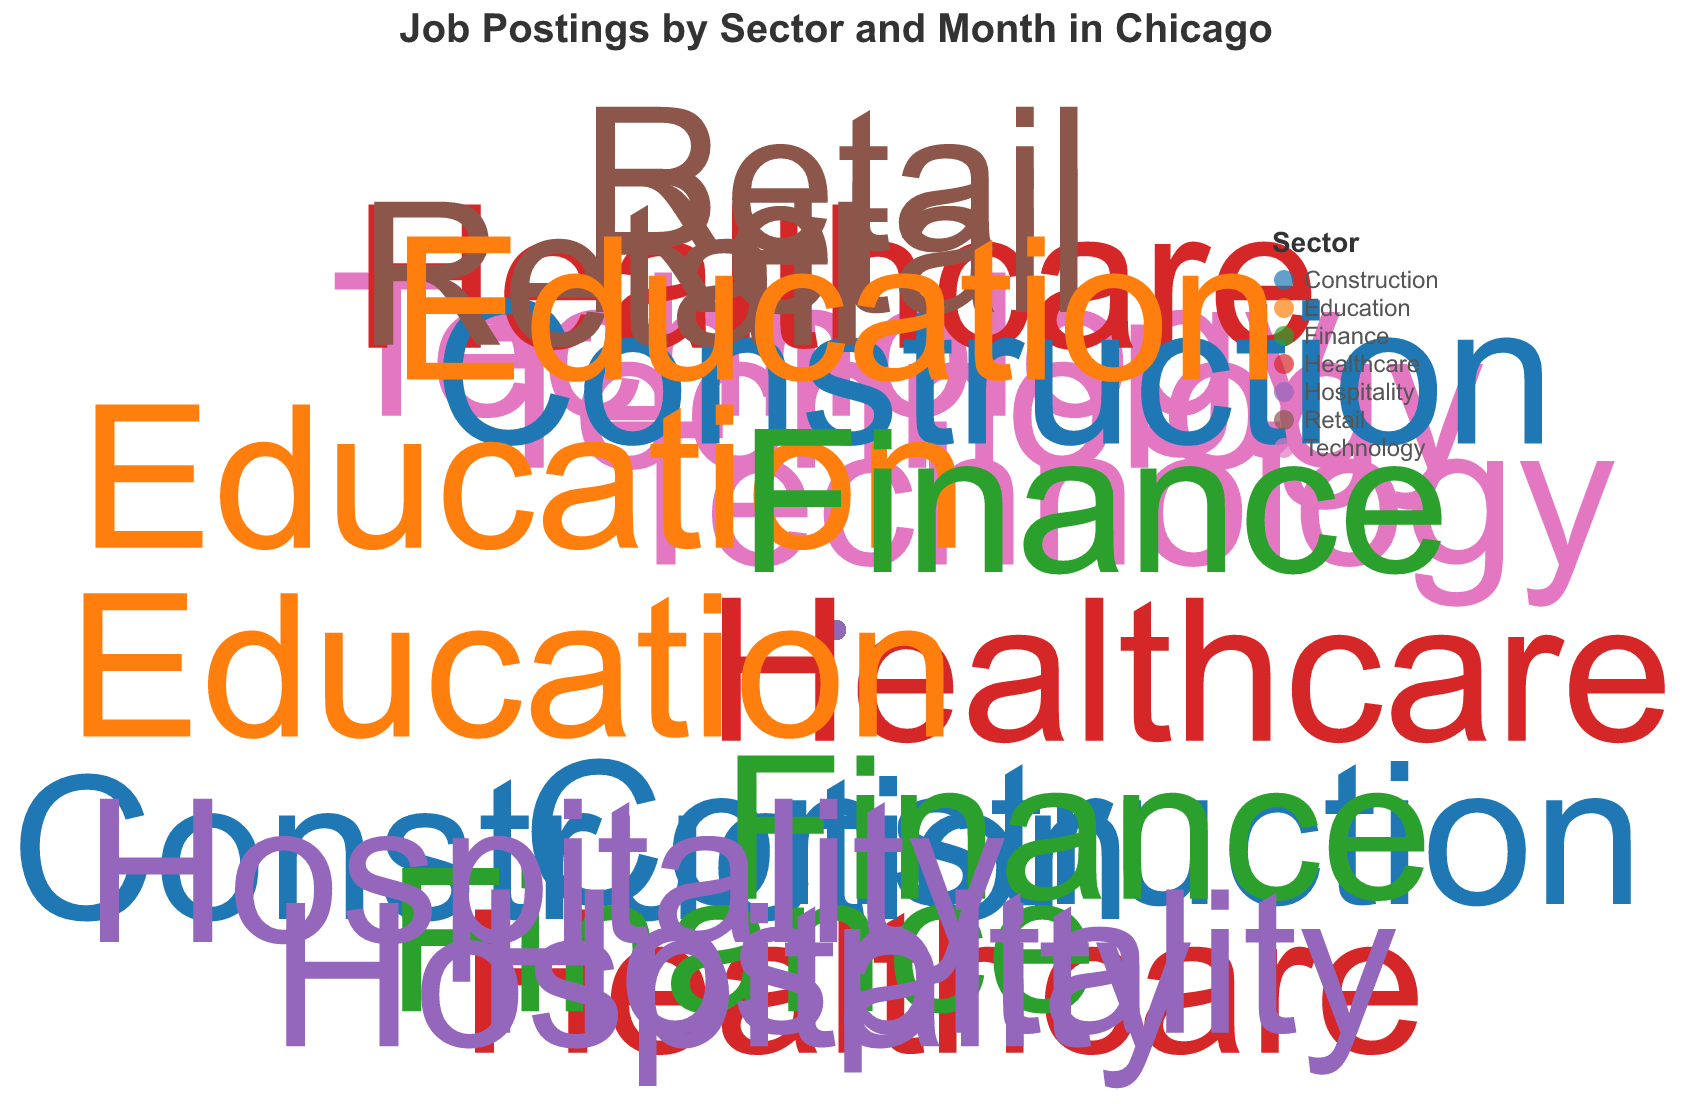What sector has the highest number of job postings in December? Look for the marker corresponding to December and check the sector with the highest radius (job postings). In December, Retail has the highest number of job postings with 350 from Walmart.
Answer: Retail Which month has the highest job postings for the Healthcare sector? Check the radius (job postings) for each Healthcare sector marker by month. The largest radius for Healthcare is in June, with 250 job postings from UChicago Medicine.
Answer: June In which month does the Construction sector have the lowest job postings? Look through all months for the Construction sector data points and find the one with the smallest radius. The smallest radius is February, with 140 job postings from Turner Construction.
Answer: February Which sectors have job postings in July, and what are the job postings for each? Identify all markers for the month of July and note their respective sectors and job postings. The sectors in July are Finance with 190 job postings (Goldman Sachs) and Hospitality with 240 job postings (Hilton Hotels).
Answer: Finance (190), Hospitality (240) What are the total job postings for the Retail sector over all months? Sum the job postings for the Retail sector across all listed months. January (250) + November (300) + December (350) = 900.
Answer: 900 Which sector has a job posting in August and a different one in May, and how many job postings are in each month? Check the markers for August and May, then identify and compare sectors. Construction has job postings in August (210 from Skender Construction) and May (180 from Clark Construction).
Answer: Construction, 210 in August, 180 in May How do job postings for the Education sector in October compare to the job postings in September? Compare the radii for Education data points in September and October. In September, there are 180 job postings (University of Chicago), and in October, there are 200 job postings (DePaul University).
Answer: October has more job postings than September Which company posted the highest number of job postings, and in which month and sector? Identify the marker with the largest radius and note the associated company, month, and sector. Walmart in the Retail sector had the highest with 350 job postings in December.
Answer: Walmart, December, Retail What sectors have more than one month of job postings, and which months are they? Review each sector for multiple markers and list their months. Healthcare (January, April, June), Construction (February, May, August), Retail (January, November, December), Education (September, October, December), Finance (March, May, July), Hospitality (June, July, August).
Answer: Healthcare: January, April, June; Construction: February, May, August; Retail: January, November, December; Education: September, October, December; Finance: March, May, July; Hospitality: June, July, August 